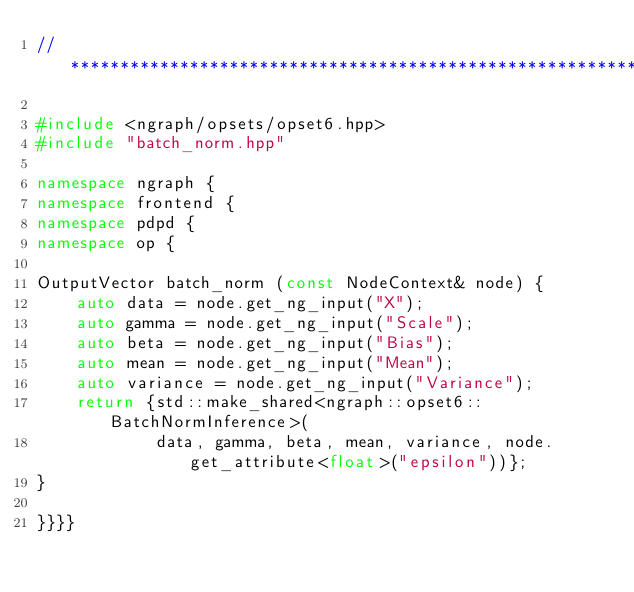Convert code to text. <code><loc_0><loc_0><loc_500><loc_500><_C++_>//*****************************************************************************

#include <ngraph/opsets/opset6.hpp>
#include "batch_norm.hpp"

namespace ngraph {
namespace frontend {
namespace pdpd {
namespace op {

OutputVector batch_norm (const NodeContext& node) {
    auto data = node.get_ng_input("X");
    auto gamma = node.get_ng_input("Scale");
    auto beta = node.get_ng_input("Bias");
    auto mean = node.get_ng_input("Mean");
    auto variance = node.get_ng_input("Variance");
    return {std::make_shared<ngraph::opset6::BatchNormInference>(
            data, gamma, beta, mean, variance, node.get_attribute<float>("epsilon"))};
}

}}}}</code> 